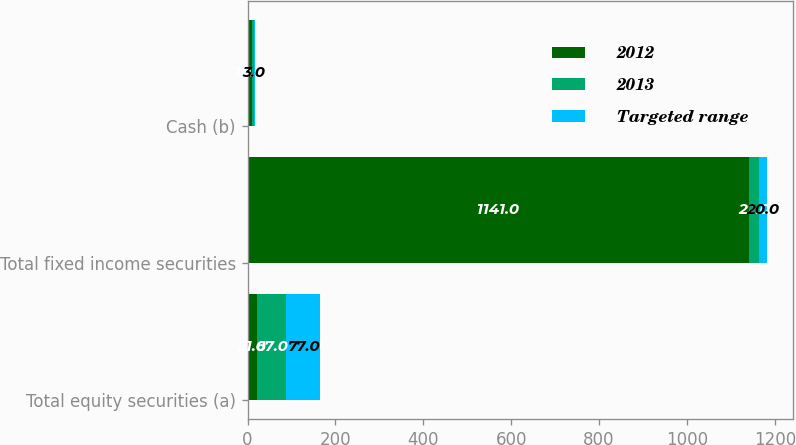Convert chart to OTSL. <chart><loc_0><loc_0><loc_500><loc_500><stacked_bar_chart><ecel><fcel>Total equity securities (a)<fcel>Total fixed income securities<fcel>Cash (b)<nl><fcel>2012<fcel>21<fcel>1141<fcel>10<nl><fcel>2013<fcel>67<fcel>22<fcel>4<nl><fcel>Targeted range<fcel>77<fcel>20<fcel>3<nl></chart> 